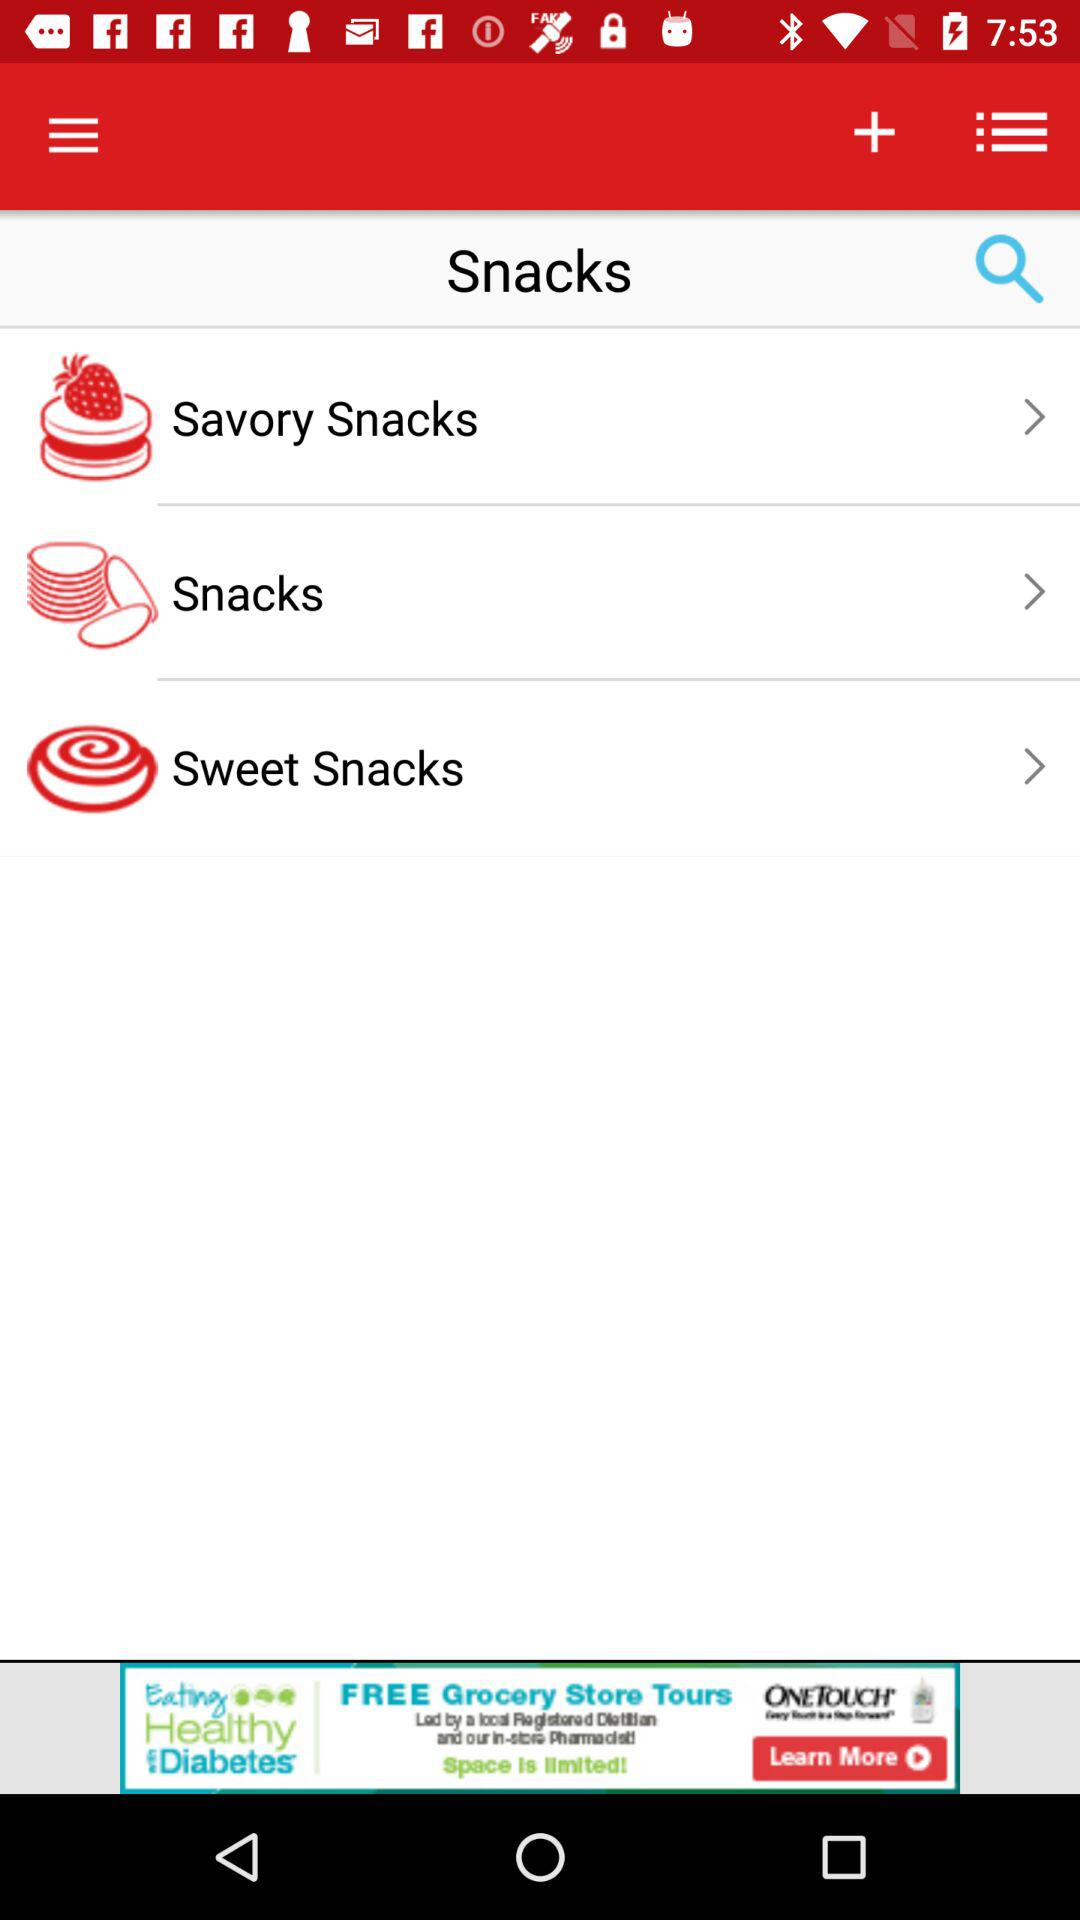What are the different snack categories available? The different snacks categories are "Savory Snacks", "Snacks", and "Sweet Snacks". 